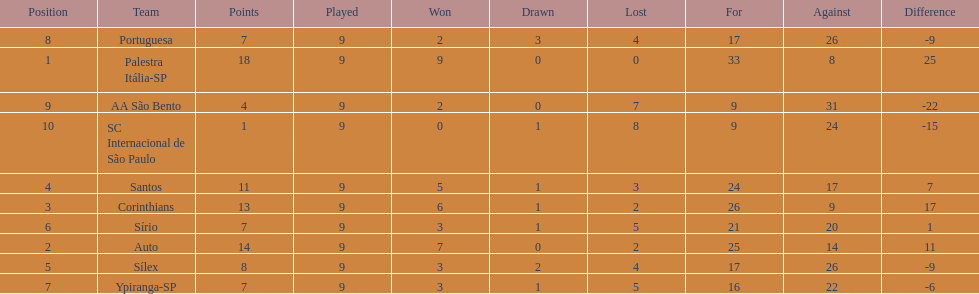In 1926 brazilian soccer, what was the overall sum of points achieved? 90. 